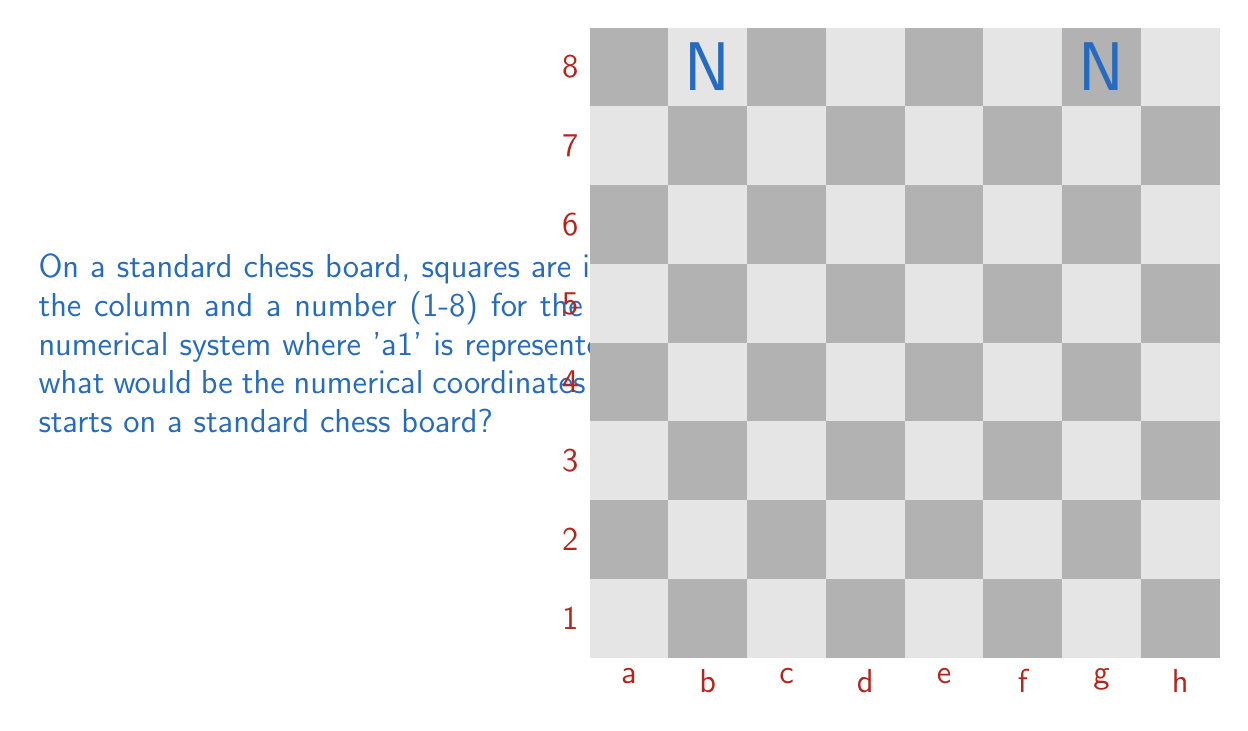Provide a solution to this math problem. Let's approach this step-by-step:

1) In a standard chess setup, knights start on b1 and g1 for White, and b8 and g8 for Black.

2) We need to convert these chess notations to numerical coordinates.

3) For the column:
   - 'a' corresponds to 1
   - 'b' corresponds to 2
   - 'g' corresponds to 7

4) For the row:
   - '1' corresponds to 1
   - '8' corresponds to 8

5) Therefore:
   - b1 converts to (2,1)
   - g1 converts to (7,1)
   - b8 converts to (2,8)
   - g8 converts to (7,8)

6) The question asks for the coordinates where a knight starts, which could be any of these positions.

7) We can express this as a set of coordinates: $\{(2,1), (7,1), (2,8), (7,8)\}$
Answer: $\{(2,1), (7,1), (2,8), (7,8)\}$ 